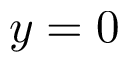Convert formula to latex. <formula><loc_0><loc_0><loc_500><loc_500>y = 0</formula> 